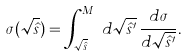Convert formula to latex. <formula><loc_0><loc_0><loc_500><loc_500>\sigma ( \sqrt { \hat { s } } ) = \int _ { \sqrt { \hat { s } } } ^ { M _ { S } } d \sqrt { \hat { s } ^ { \prime } } \, \frac { d \sigma } { d \sqrt { \hat { s } ^ { \prime } } } .</formula> 